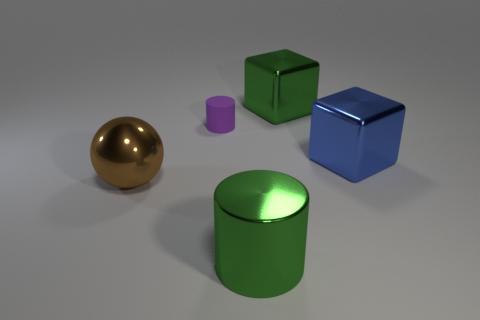Which object in the image is the tallest? The green cylindrical object stands out as the tallest in the group. Its height surpasses that of the other items, which include the shorter purple cylinder, the blue cube, and the compact gold and green shapes. Could you estimate the proportions of the objects relative to each other? While exact measurements are not possible from this image alone, relative to each other, the green cylinder seems about twice the height of the blue cube. The gold sphere's diameter might be just slightly smaller than the height of the purple cylinder, and the green cube appears to be of almost equal dimensions on all sides. 